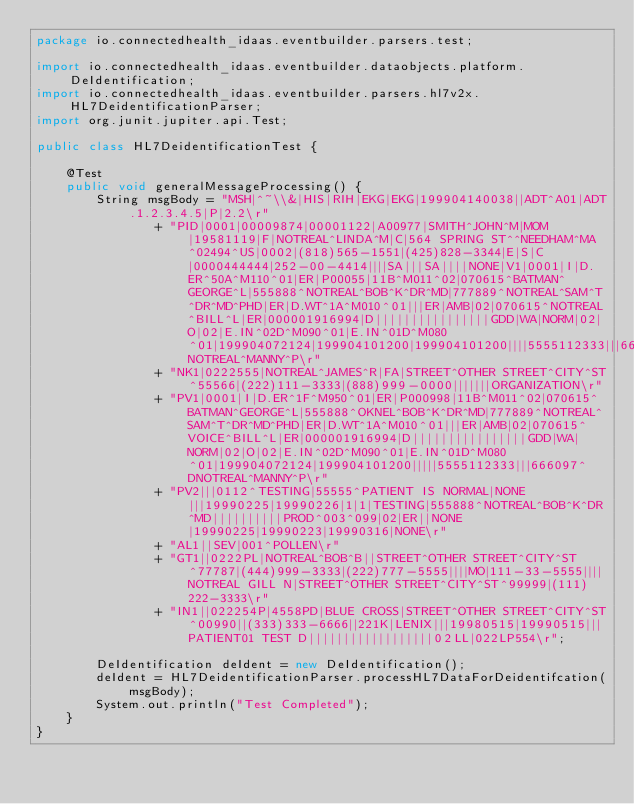Convert code to text. <code><loc_0><loc_0><loc_500><loc_500><_Java_>package io.connectedhealth_idaas.eventbuilder.parsers.test;

import io.connectedhealth_idaas.eventbuilder.dataobjects.platform.DeIdentification;
import io.connectedhealth_idaas.eventbuilder.parsers.hl7v2x.HL7DeidentificationParser;
import org.junit.jupiter.api.Test;

public class HL7DeidentificationTest {

    @Test
    public void generalMessageProcessing() {
        String msgBody = "MSH|^~\\&|HIS|RIH|EKG|EKG|199904140038||ADT^A01|ADT.1.2.3.4.5|P|2.2\r"
                + "PID|0001|00009874|00001122|A00977|SMITH^JOHN^M|MOM|19581119|F|NOTREAL^LINDA^M|C|564 SPRING ST^^NEEDHAM^MA^02494^US|0002|(818)565-1551|(425)828-3344|E|S|C|0000444444|252-00-4414||||SA|||SA||||NONE|V1|0001|I|D.ER^50A^M110^01|ER|P00055|11B^M011^02|070615^BATMAN^GEORGE^L|555888^NOTREAL^BOB^K^DR^MD|777889^NOTREAL^SAM^T^DR^MD^PHD|ER|D.WT^1A^M010^01|||ER|AMB|02|070615^NOTREAL^BILL^L|ER|000001916994|D||||||||||||||||GDD|WA|NORM|02|O|02|E.IN^02D^M090^01|E.IN^01D^M080^01|199904072124|199904101200|199904101200||||5555112333|||666097^NOTREAL^MANNY^P\r"
                + "NK1|0222555|NOTREAL^JAMES^R|FA|STREET^OTHER STREET^CITY^ST^55566|(222)111-3333|(888)999-0000|||||||ORGANIZATION\r"
                + "PV1|0001|I|D.ER^1F^M950^01|ER|P000998|11B^M011^02|070615^BATMAN^GEORGE^L|555888^OKNEL^BOB^K^DR^MD|777889^NOTREAL^SAM^T^DR^MD^PHD|ER|D.WT^1A^M010^01|||ER|AMB|02|070615^VOICE^BILL^L|ER|000001916994|D||||||||||||||||GDD|WA|NORM|02|O|02|E.IN^02D^M090^01|E.IN^01D^M080^01|199904072124|199904101200|||||5555112333|||666097^DNOTREAL^MANNY^P\r"
                + "PV2|||0112^TESTING|55555^PATIENT IS NORMAL|NONE|||19990225|19990226|1|1|TESTING|555888^NOTREAL^BOB^K^DR^MD||||||||||PROD^003^099|02|ER||NONE|19990225|19990223|19990316|NONE\r"
                + "AL1||SEV|001^POLLEN\r"
                + "GT1||0222PL|NOTREAL^BOB^B||STREET^OTHER STREET^CITY^ST^77787|(444)999-3333|(222)777-5555||||MO|111-33-5555||||NOTREAL GILL N|STREET^OTHER STREET^CITY^ST^99999|(111)222-3333\r"
                + "IN1||022254P|4558PD|BLUE CROSS|STREET^OTHER STREET^CITY^ST^00990||(333)333-6666||221K|LENIX|||19980515|19990515|||PATIENT01 TEST D||||||||||||||||||02LL|022LP554\r";

        DeIdentification deIdent = new DeIdentification();
        deIdent = HL7DeidentificationParser.processHL7DataForDeidentifcation(msgBody);
        System.out.println("Test Completed");
    }
}</code> 